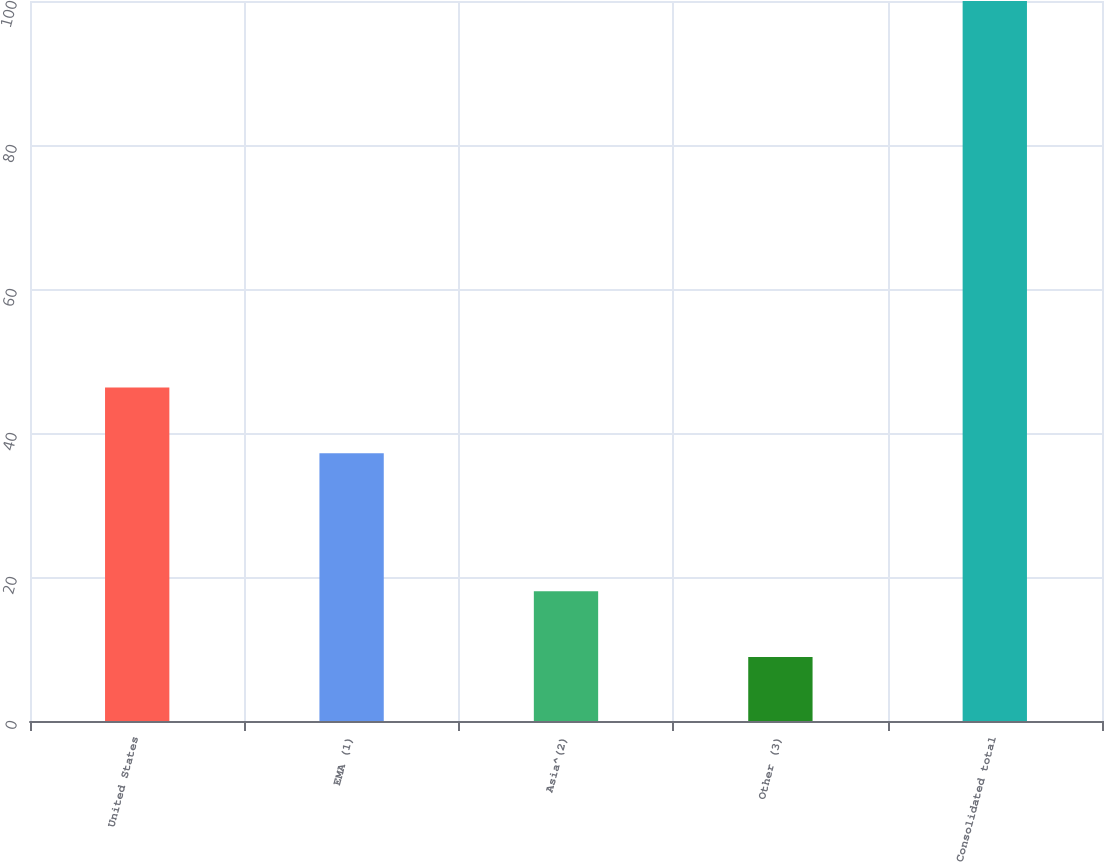Convert chart. <chart><loc_0><loc_0><loc_500><loc_500><bar_chart><fcel>United States<fcel>EMA (1)<fcel>Asia^(2)<fcel>Other (3)<fcel>Consolidated total<nl><fcel>46.31<fcel>37.2<fcel>18.01<fcel>8.9<fcel>100<nl></chart> 